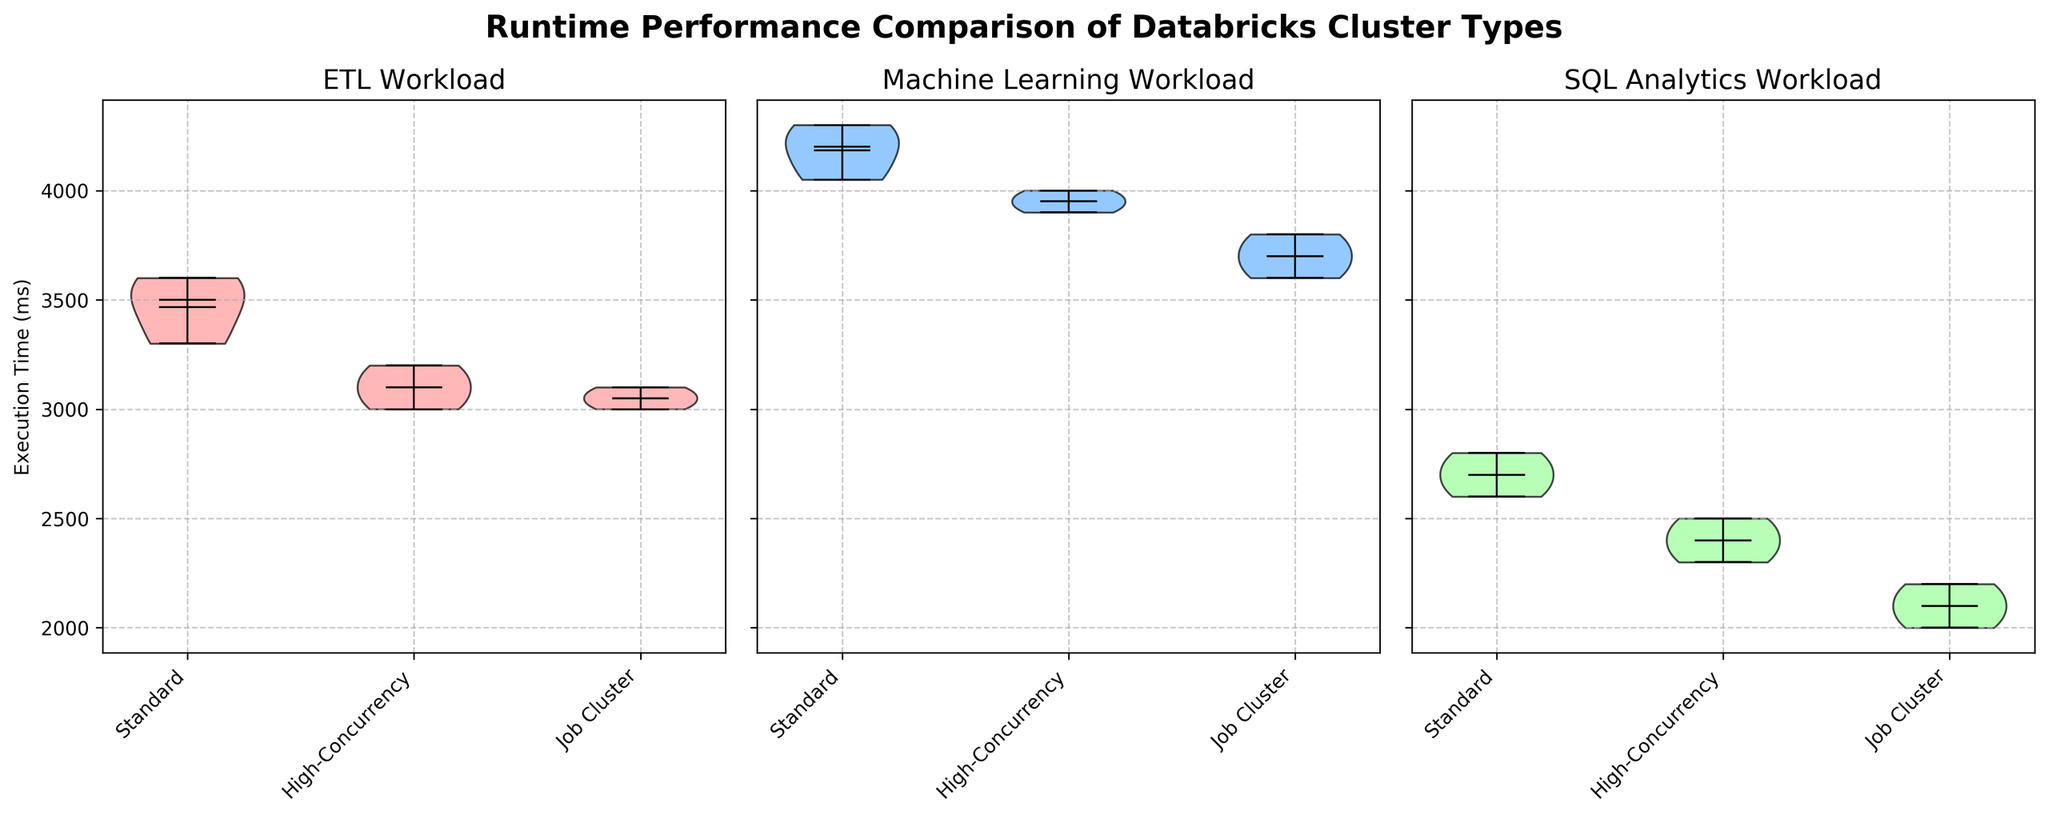What are the dimensions of each subplot? Each subplot shows the runtime performance for a specific workload: ETL, Machine Learning, and SQL Analytics. The dimensions are consistent, with each subplot having a title, x-axis (with three categories: Standard, High-Concurrency, Job Cluster), and y-axis (execution time in milliseconds).
Answer: 3 subplots What is the title of the figure? The title is positioned at the top center of the figure and reads "Runtime Performance Comparison of Databricks Cluster Types". It is emphasized with a bold font and larger font size.
Answer: Runtime Performance Comparison of Databricks Cluster Types Which cluster type has the median execution time for SQL Analytics workload closest to 2000 ms? The median is denoted by the line within the violin plots. For SQL Analytics workload, the Job Cluster has a median close to 2000 ms.
Answer: Job Cluster Which workload shows the highest mean execution time for the Standard cluster? The mean is indicated by a dot within the violin plot. For the Standard cluster, the Machine Learning workload has the highest mean execution time.
Answer: Machine Learning How does the execution time distribution for ETL differ between the Standard and High-Concurrency clusters? Examine the shape and position of the violin plots for ETL under Standard and High-Concurrency clusters. The High-Concurrency cluster has a slightly lower and more compact distribution compared to the Standard cluster.
Answer: High-Concurrency is lower and more compact Which workload has the widest range of execution times for the Job Cluster? The range is shown by the vertical span of the violin plot. For the Job Cluster, the Machine Learning workload has the widest distribution.
Answer: Machine Learning Is there any workload where the High-Concurrency cluster consistently outperforms the Job Cluster? Compare the position and shape of the violin plots for each workload. For SQL Analytics, High-Concurrency cluster has consistently higher execution times than the Job Cluster.
Answer: No Across all cluster types, which workload has the lowest median execution time? Compare the median lines within each workload's violin plots. The SQL Analytics workload has the lowest median execution times across all cluster types.
Answer: SQL Analytics Are there any workloads where the mean execution times for different cluster types are similar? Look at the dots representing the means within the violin plots. For the ETL workload, the means for High-Concurrency and Job Cluster are similar.
Answer: ETL Which workload's execution time shows the least variation for the Standard cluster? The least variation is indicated by the narrowest violin plot. For the Standard cluster, SQL Analytics workload shows the least variation.
Answer: SQL Analytics 